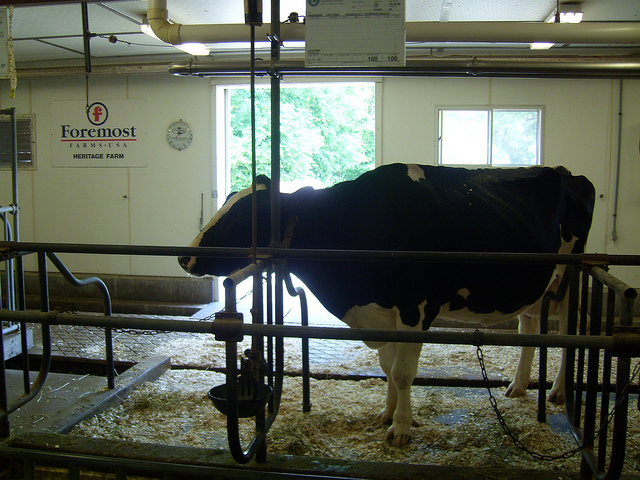Identify and read out the text in this image. USA FARM HERITAGE FARMS Foremost F 